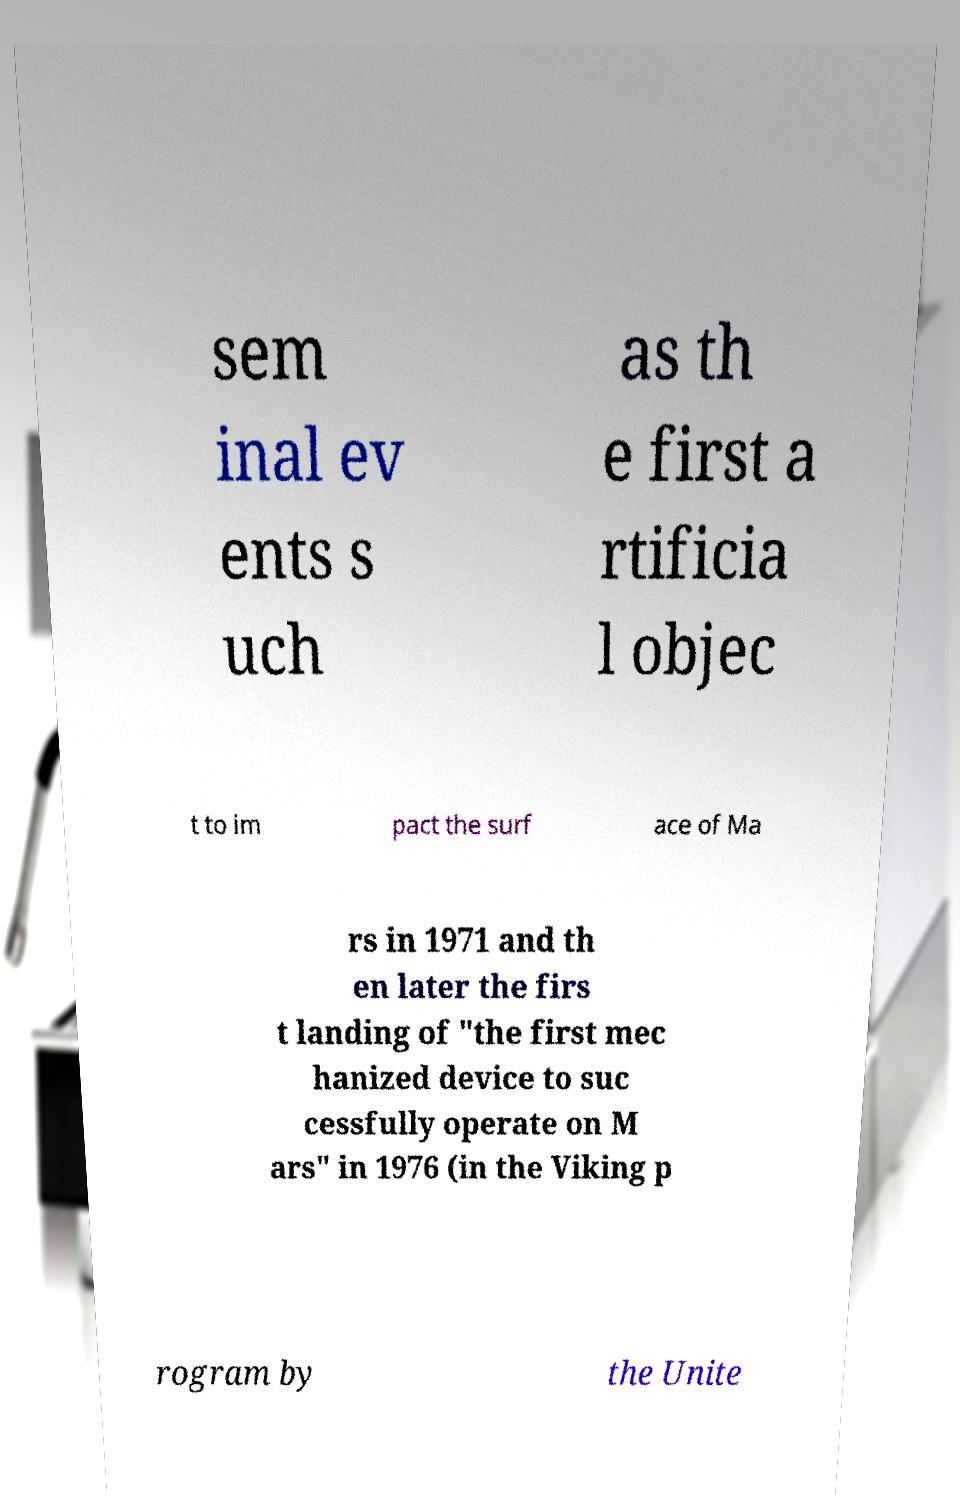I need the written content from this picture converted into text. Can you do that? sem inal ev ents s uch as th e first a rtificia l objec t to im pact the surf ace of Ma rs in 1971 and th en later the firs t landing of "the first mec hanized device to suc cessfully operate on M ars" in 1976 (in the Viking p rogram by the Unite 